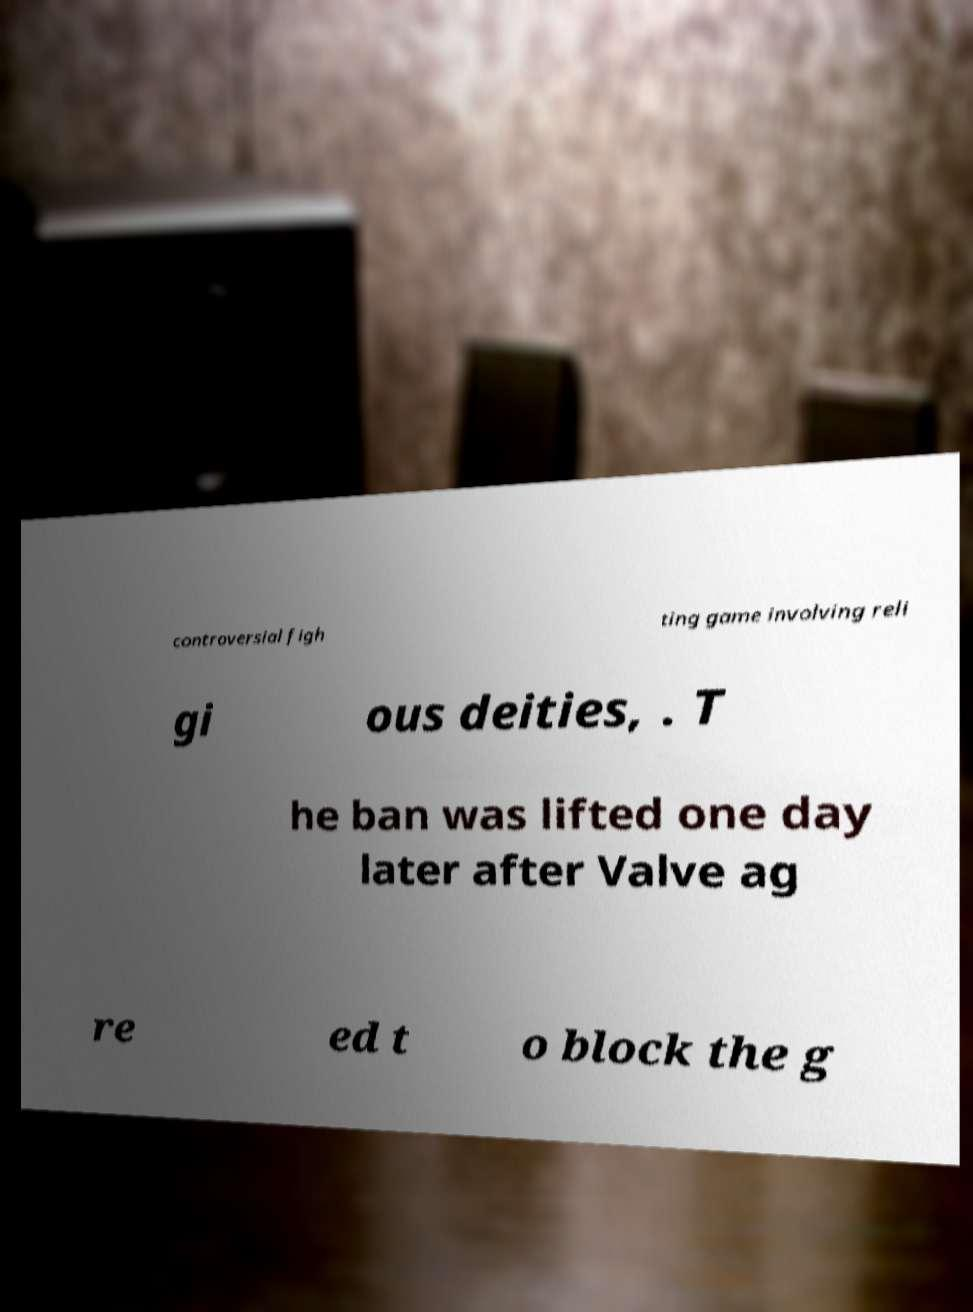Can you accurately transcribe the text from the provided image for me? controversial figh ting game involving reli gi ous deities, . T he ban was lifted one day later after Valve ag re ed t o block the g 